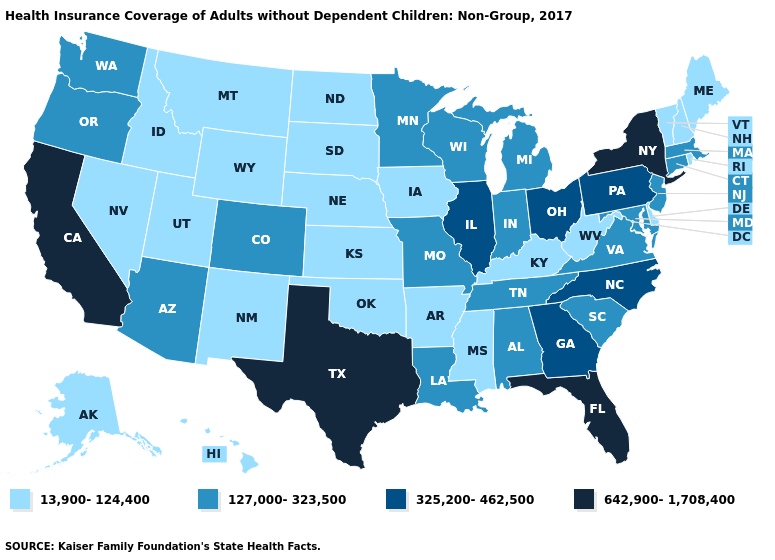Does the map have missing data?
Short answer required. No. How many symbols are there in the legend?
Write a very short answer. 4. Which states have the lowest value in the USA?
Give a very brief answer. Alaska, Arkansas, Delaware, Hawaii, Idaho, Iowa, Kansas, Kentucky, Maine, Mississippi, Montana, Nebraska, Nevada, New Hampshire, New Mexico, North Dakota, Oklahoma, Rhode Island, South Dakota, Utah, Vermont, West Virginia, Wyoming. Does South Dakota have the lowest value in the USA?
Write a very short answer. Yes. Does the map have missing data?
Write a very short answer. No. Name the states that have a value in the range 13,900-124,400?
Keep it brief. Alaska, Arkansas, Delaware, Hawaii, Idaho, Iowa, Kansas, Kentucky, Maine, Mississippi, Montana, Nebraska, Nevada, New Hampshire, New Mexico, North Dakota, Oklahoma, Rhode Island, South Dakota, Utah, Vermont, West Virginia, Wyoming. Among the states that border South Carolina , which have the highest value?
Answer briefly. Georgia, North Carolina. What is the value of South Dakota?
Keep it brief. 13,900-124,400. What is the value of Missouri?
Give a very brief answer. 127,000-323,500. Which states have the lowest value in the MidWest?
Be succinct. Iowa, Kansas, Nebraska, North Dakota, South Dakota. Does Mississippi have the lowest value in the USA?
Concise answer only. Yes. What is the value of Mississippi?
Short answer required. 13,900-124,400. Is the legend a continuous bar?
Keep it brief. No. Among the states that border Iowa , does Wisconsin have the lowest value?
Be succinct. No. Which states have the highest value in the USA?
Answer briefly. California, Florida, New York, Texas. 